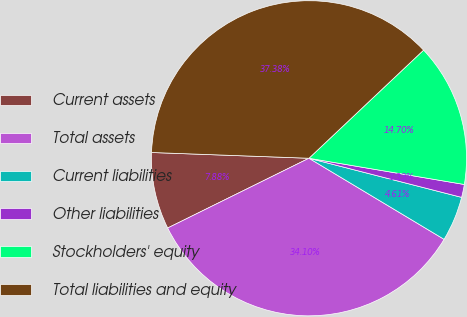<chart> <loc_0><loc_0><loc_500><loc_500><pie_chart><fcel>Current assets<fcel>Total assets<fcel>Current liabilities<fcel>Other liabilities<fcel>Stockholders' equity<fcel>Total liabilities and equity<nl><fcel>7.88%<fcel>34.1%<fcel>4.61%<fcel>1.33%<fcel>14.7%<fcel>37.38%<nl></chart> 